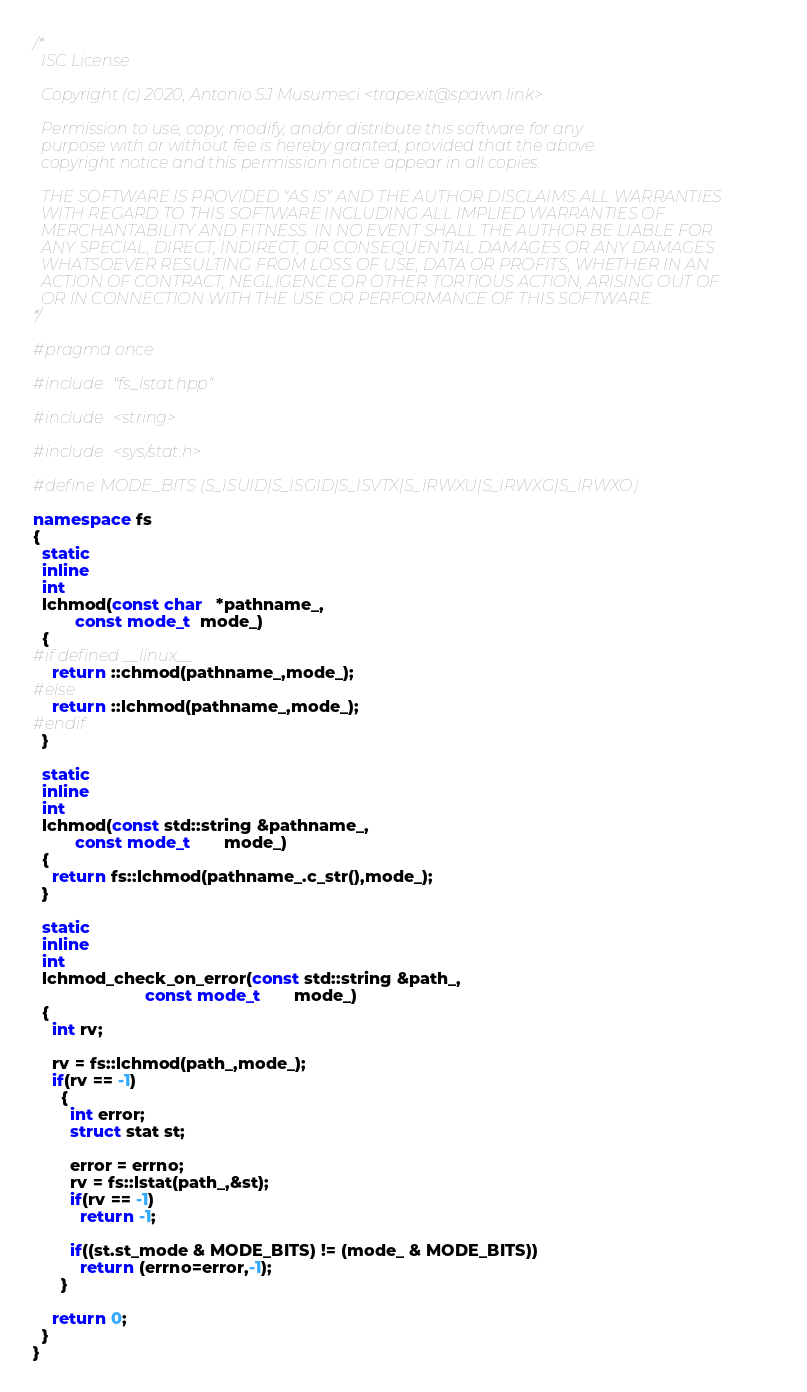Convert code to text. <code><loc_0><loc_0><loc_500><loc_500><_C++_>/*
  ISC License

  Copyright (c) 2020, Antonio SJ Musumeci <trapexit@spawn.link>

  Permission to use, copy, modify, and/or distribute this software for any
  purpose with or without fee is hereby granted, provided that the above
  copyright notice and this permission notice appear in all copies.

  THE SOFTWARE IS PROVIDED "AS IS" AND THE AUTHOR DISCLAIMS ALL WARRANTIES
  WITH REGARD TO THIS SOFTWARE INCLUDING ALL IMPLIED WARRANTIES OF
  MERCHANTABILITY AND FITNESS. IN NO EVENT SHALL THE AUTHOR BE LIABLE FOR
  ANY SPECIAL, DIRECT, INDIRECT, OR CONSEQUENTIAL DAMAGES OR ANY DAMAGES
  WHATSOEVER RESULTING FROM LOSS OF USE, DATA OR PROFITS, WHETHER IN AN
  ACTION OF CONTRACT, NEGLIGENCE OR OTHER TORTIOUS ACTION, ARISING OUT OF
  OR IN CONNECTION WITH THE USE OR PERFORMANCE OF THIS SOFTWARE.
*/

#pragma once

#include "fs_lstat.hpp"

#include <string>

#include <sys/stat.h>

#define MODE_BITS (S_ISUID|S_ISGID|S_ISVTX|S_IRWXU|S_IRWXG|S_IRWXO)

namespace fs
{
  static
  inline
  int
  lchmod(const char   *pathname_,
         const mode_t  mode_)
  {
#if defined __linux__
    return ::chmod(pathname_,mode_);
#else
    return ::lchmod(pathname_,mode_);
#endif
  }

  static
  inline
  int
  lchmod(const std::string &pathname_,
         const mode_t       mode_)
  {
    return fs::lchmod(pathname_.c_str(),mode_);
  }

  static
  inline
  int
  lchmod_check_on_error(const std::string &path_,
                        const mode_t       mode_)
  {
    int rv;

    rv = fs::lchmod(path_,mode_);
    if(rv == -1)
      {
        int error;
        struct stat st;

        error = errno;
        rv = fs::lstat(path_,&st);
        if(rv == -1)
          return -1;

        if((st.st_mode & MODE_BITS) != (mode_ & MODE_BITS))
          return (errno=error,-1);
      }

    return 0;
  }
}
</code> 